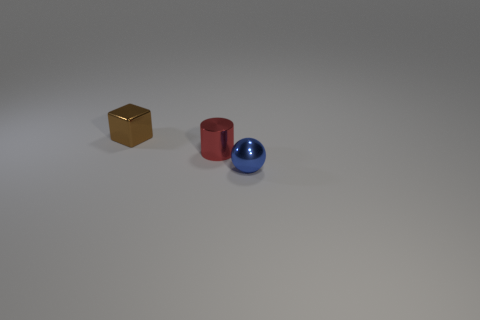What number of balls are either small blue things or red objects?
Provide a short and direct response. 1. What is the color of the cylinder that is the same size as the blue object?
Offer a very short reply. Red. The blue metal thing has what size?
Offer a very short reply. Small. How many things are either big red metal spheres or small metal cylinders?
Your response must be concise. 1. There is a ball that is made of the same material as the cylinder; what is its color?
Make the answer very short. Blue. Do the shiny thing that is to the left of the metal cylinder and the small red metallic object have the same shape?
Provide a succinct answer. No. How many things are metallic things on the right side of the brown metallic thing or objects to the left of the red cylinder?
Provide a short and direct response. 3. Are there any other things that are the same shape as the tiny brown object?
Give a very brief answer. No. There is a small brown thing; does it have the same shape as the tiny shiny thing in front of the small red object?
Your answer should be very brief. No. What material is the tiny red cylinder?
Offer a terse response. Metal. 